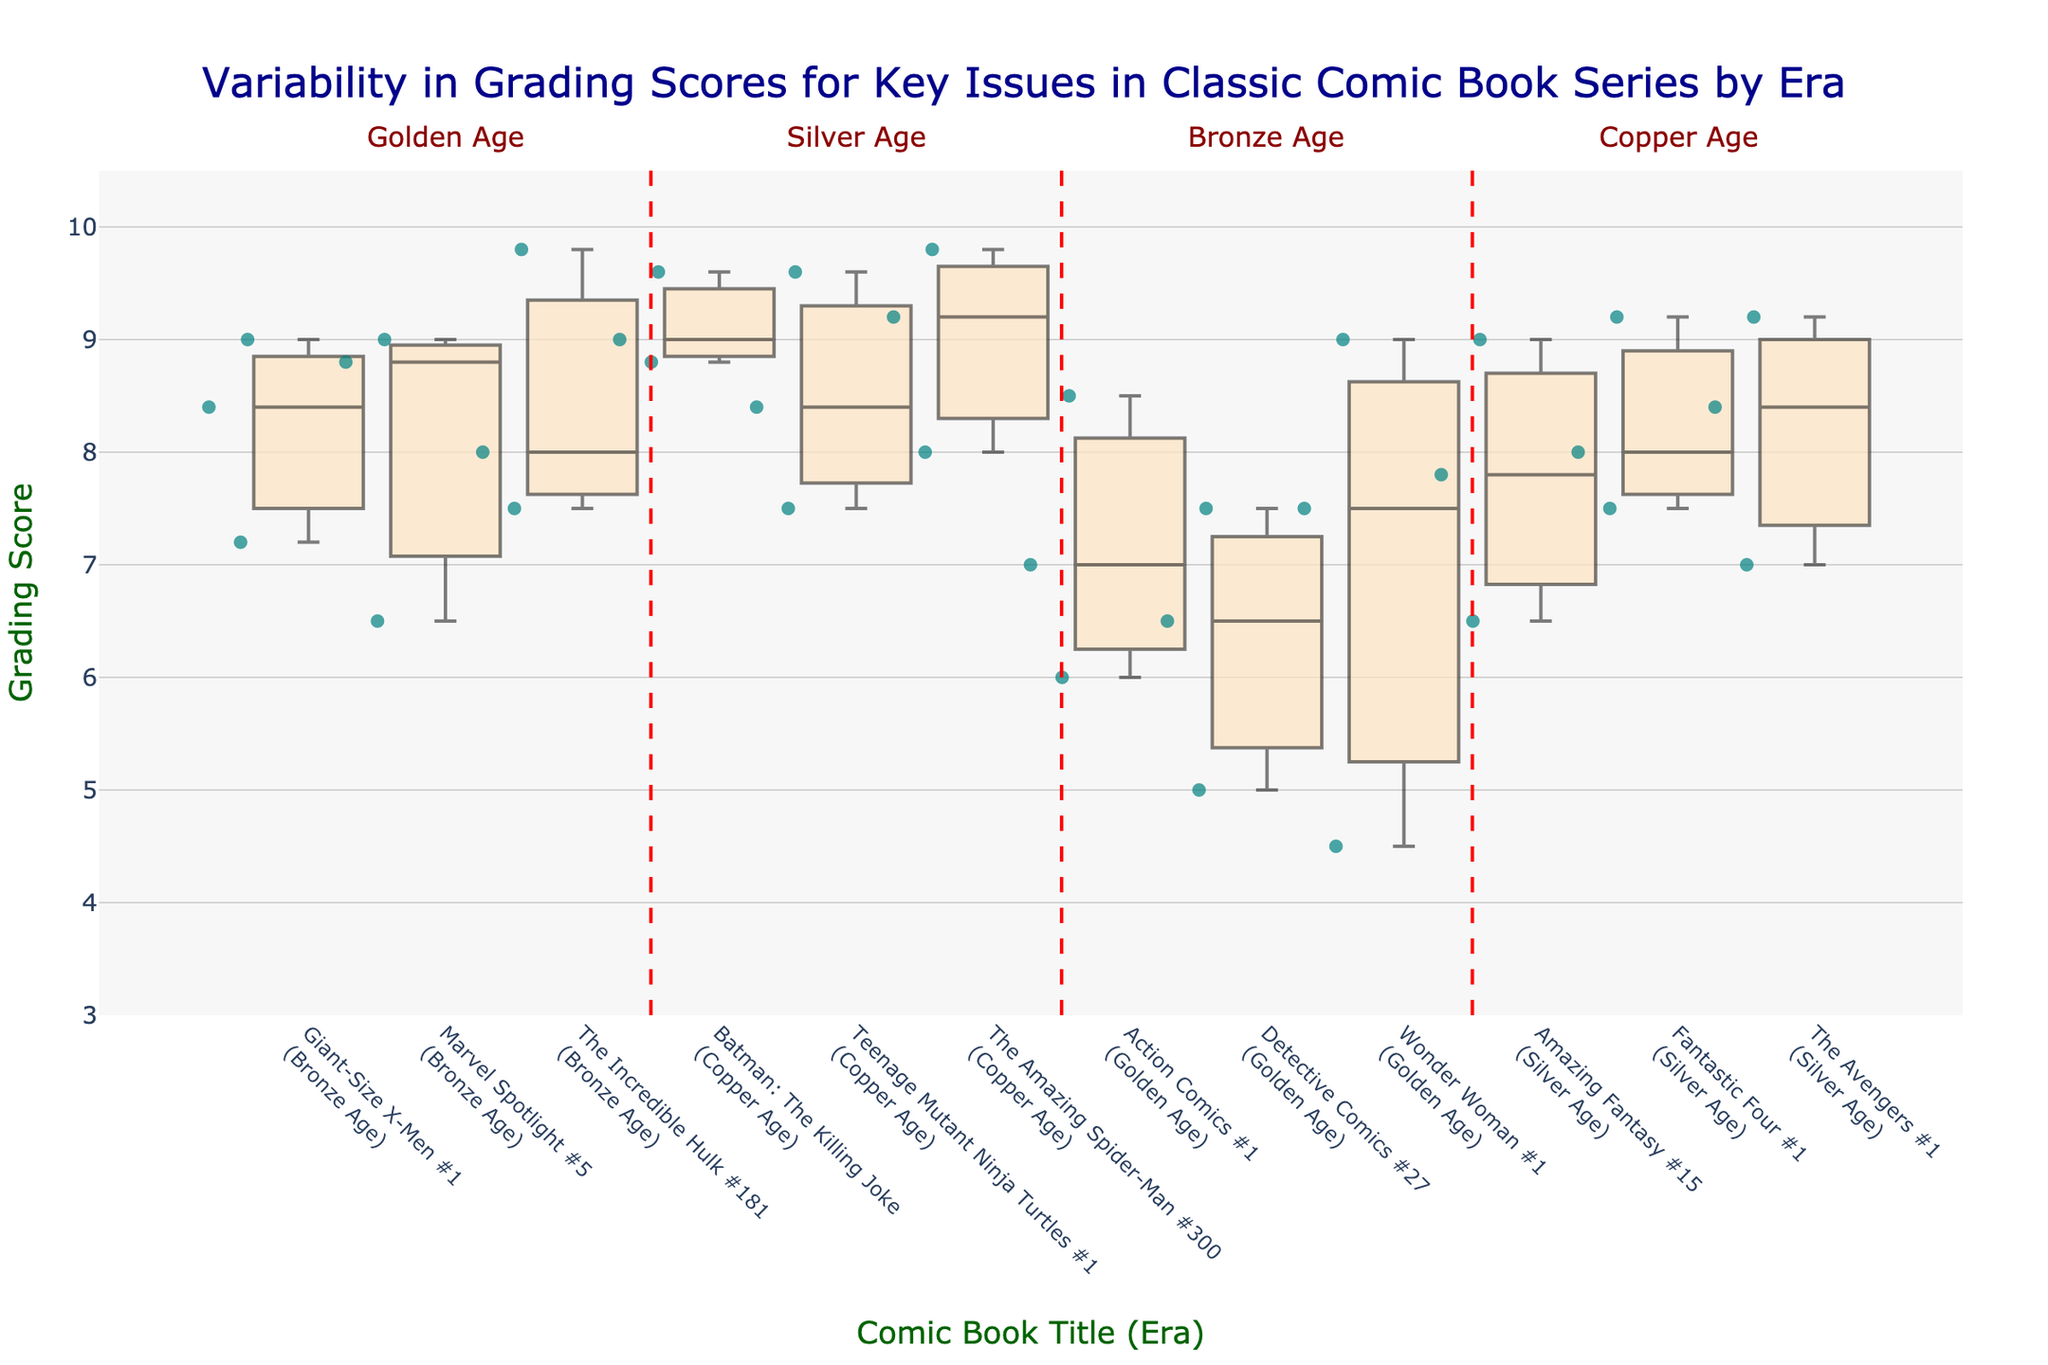what is the title of the figure? The title is prominently displayed at the top of the figure. It reads "Variability in Grading Scores for Key Issues in Classic Comic Book Series by Era."
Answer: Variability in Grading Scores for Key Issues in Classic Comic Book Series by Era What does the y-axis represent? The y-axis title is "Grading Score," indicating it represents the grading score of comic books.
Answer: Grading Score Which comic book from the Golden Age has the highest grading score? Action Comics #1 grade plot shows a data point reaching up to 8.5, which is the highest among the Golden Age comics.
Answer: Action Comics #1 Which era has the comic book with the highest grading score overall? By inspecting the plots, The Incredible Hulk #181 from the Bronze Age has the highest score at 9.8.
Answer: Bronze Age Which comic book in the Silver Age has the widest variation in grading scores? The variation in grading scores is represented by the range of the box plots. Fantastic Four #1 has the widest box plot in the Silver Age, indicating the largest variation.
Answer: Fantastic Four #1 Which comic book in the Copper Age has the smallest range of grading scores? Looking at the widths of the boxes for the Copper Age, Batman: The Killing Joke has the smallest range as the box plot is the most condensed.
Answer: Batman: The Killing Joke What is the median grading score of Amazing Fantasy #15? The median is the middle line within the box. For Amazing Fantasy #15, the median grading score is approximately 7.8.
Answer: 7.8 How does the variability of grading scores for Detective Comics #27 compare to that of Wonder Woman #1? Detective Comics #27's box plot shows a narrower range compared to Wonder Woman #1, indicating less variability in its grading scores.
Answer: Detective Comics #27 has less variability What is the range of grading scores for The Incredible Hulk #181? The range is the difference between the highest and lowest scores. For The Incredible Hulk #181, the highest grading score is 9.8 and the lowest is 7.5, so the range is 9.8 - 7.5 = 2.3.
Answer: 2.3 Which era shows the most variability in grading scores overall? Inspecting the box plots across all eras, the Silver Age has the most variability due to larger boxes and whiskers for its comics compared to other eras.
Answer: Silver Age 